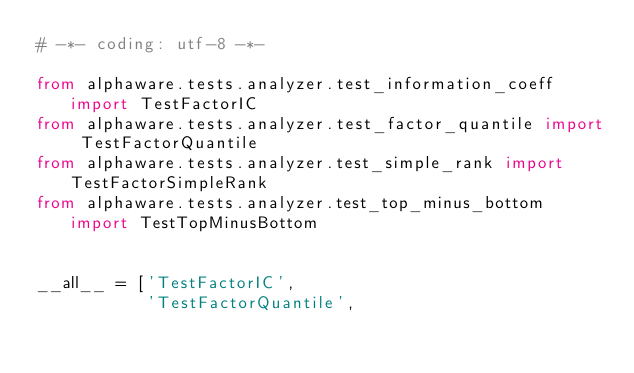<code> <loc_0><loc_0><loc_500><loc_500><_Python_># -*- coding: utf-8 -*-

from alphaware.tests.analyzer.test_information_coeff import TestFactorIC
from alphaware.tests.analyzer.test_factor_quantile import TestFactorQuantile
from alphaware.tests.analyzer.test_simple_rank import TestFactorSimpleRank
from alphaware.tests.analyzer.test_top_minus_bottom import TestTopMinusBottom


__all__ = ['TestFactorIC',
           'TestFactorQuantile',</code> 